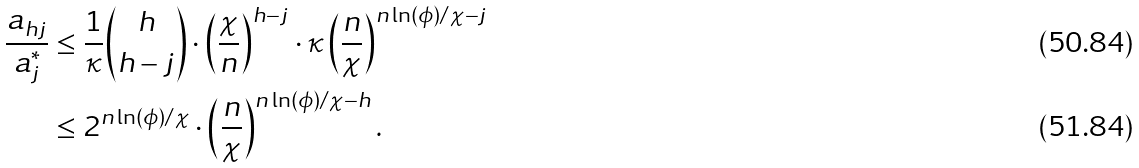<formula> <loc_0><loc_0><loc_500><loc_500>\frac { a _ { h j } } { a ^ { * } _ { j } } & \leq \frac { 1 } { \kappa } { h \choose h - j } \cdot \left ( \frac { \chi } { n } \right ) ^ { h - j } \cdot \kappa \left ( \frac { n } { \chi } \right ) ^ { n \ln ( \phi ) / \chi - j } \\ & \leq 2 ^ { n \ln ( \phi ) / \chi } \cdot \left ( \frac { n } { \chi } \right ) ^ { n \ln ( \phi ) / \chi - h } .</formula> 